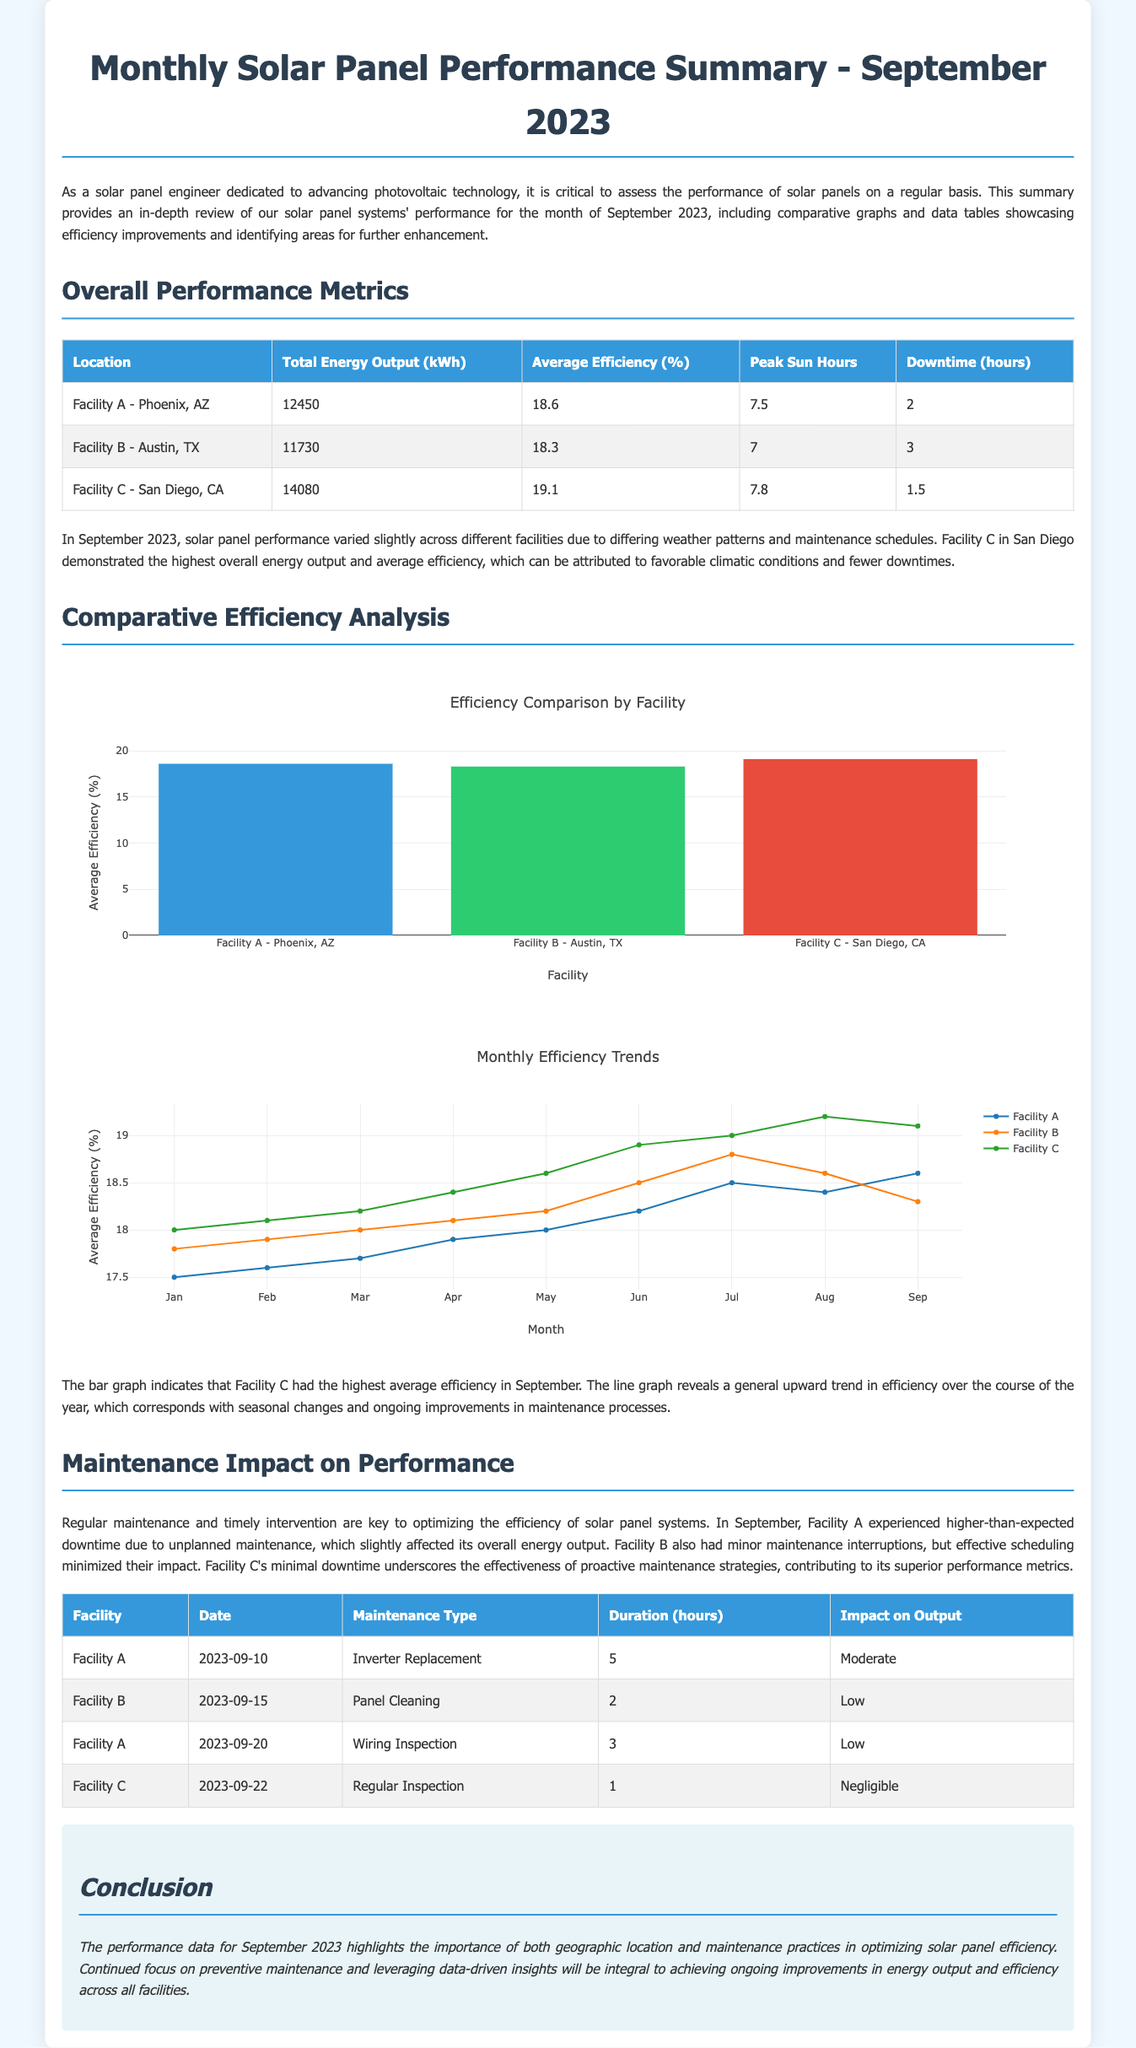What is the total energy output for Facility A? The total energy output for Facility A is specified in the Overall Performance Metrics table as 12450 kWh.
Answer: 12450 kWh What was the average efficiency of Facility C? The average efficiency for Facility C is provided in the Overall Performance Metrics table, which lists it as 19.1%.
Answer: 19.1% Which facility experienced the least downtime? The Overall Performance Metrics table indicates that Facility C had only 1.5 hours of downtime, the least among the facilities.
Answer: 1.5 hours What maintenance type was performed at Facility B on September 15, 2023? In the Maintenance Impact on Performance section, Facility B's maintenance details show that a Panel Cleaning was performed on that date.
Answer: Panel Cleaning What is the title of the first comparative graph? The title of the first comparative graph is provided in the script section for the graph, which is "Efficiency Comparison by Facility."
Answer: Efficiency Comparison by Facility Which facility had the highest total energy output? From the Overall Performance Metrics table, Facility C shows the highest total energy output at 14080 kWh.
Answer: Facility C What was the impact on output for the inverter replacement at Facility A? The impact on output for the inverter replacement at Facility A is noted in the Maintenance Impact on Performance section as moderate.
Answer: Moderate How many peak sun hours did Facility B experience? The peak sun hours for Facility B are specified in the Overall Performance Metrics table as 7 hours.
Answer: 7 hours What is the primary conclusion from the report? The primary conclusion in the Conclusion section emphasizes the importance of geographic location and maintenance practices for optimizing solar panel efficiency.
Answer: Importance of geographic location and maintenance practices 